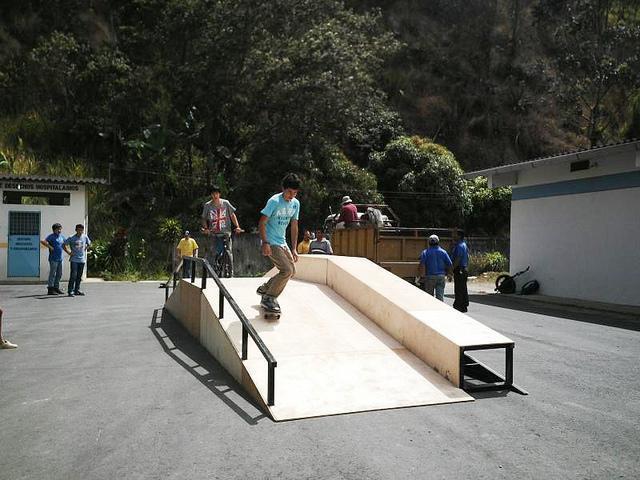How many humanoid statues are present in the photo?
Give a very brief answer. 0. How many guys are on top the ramp?
Give a very brief answer. 2. 